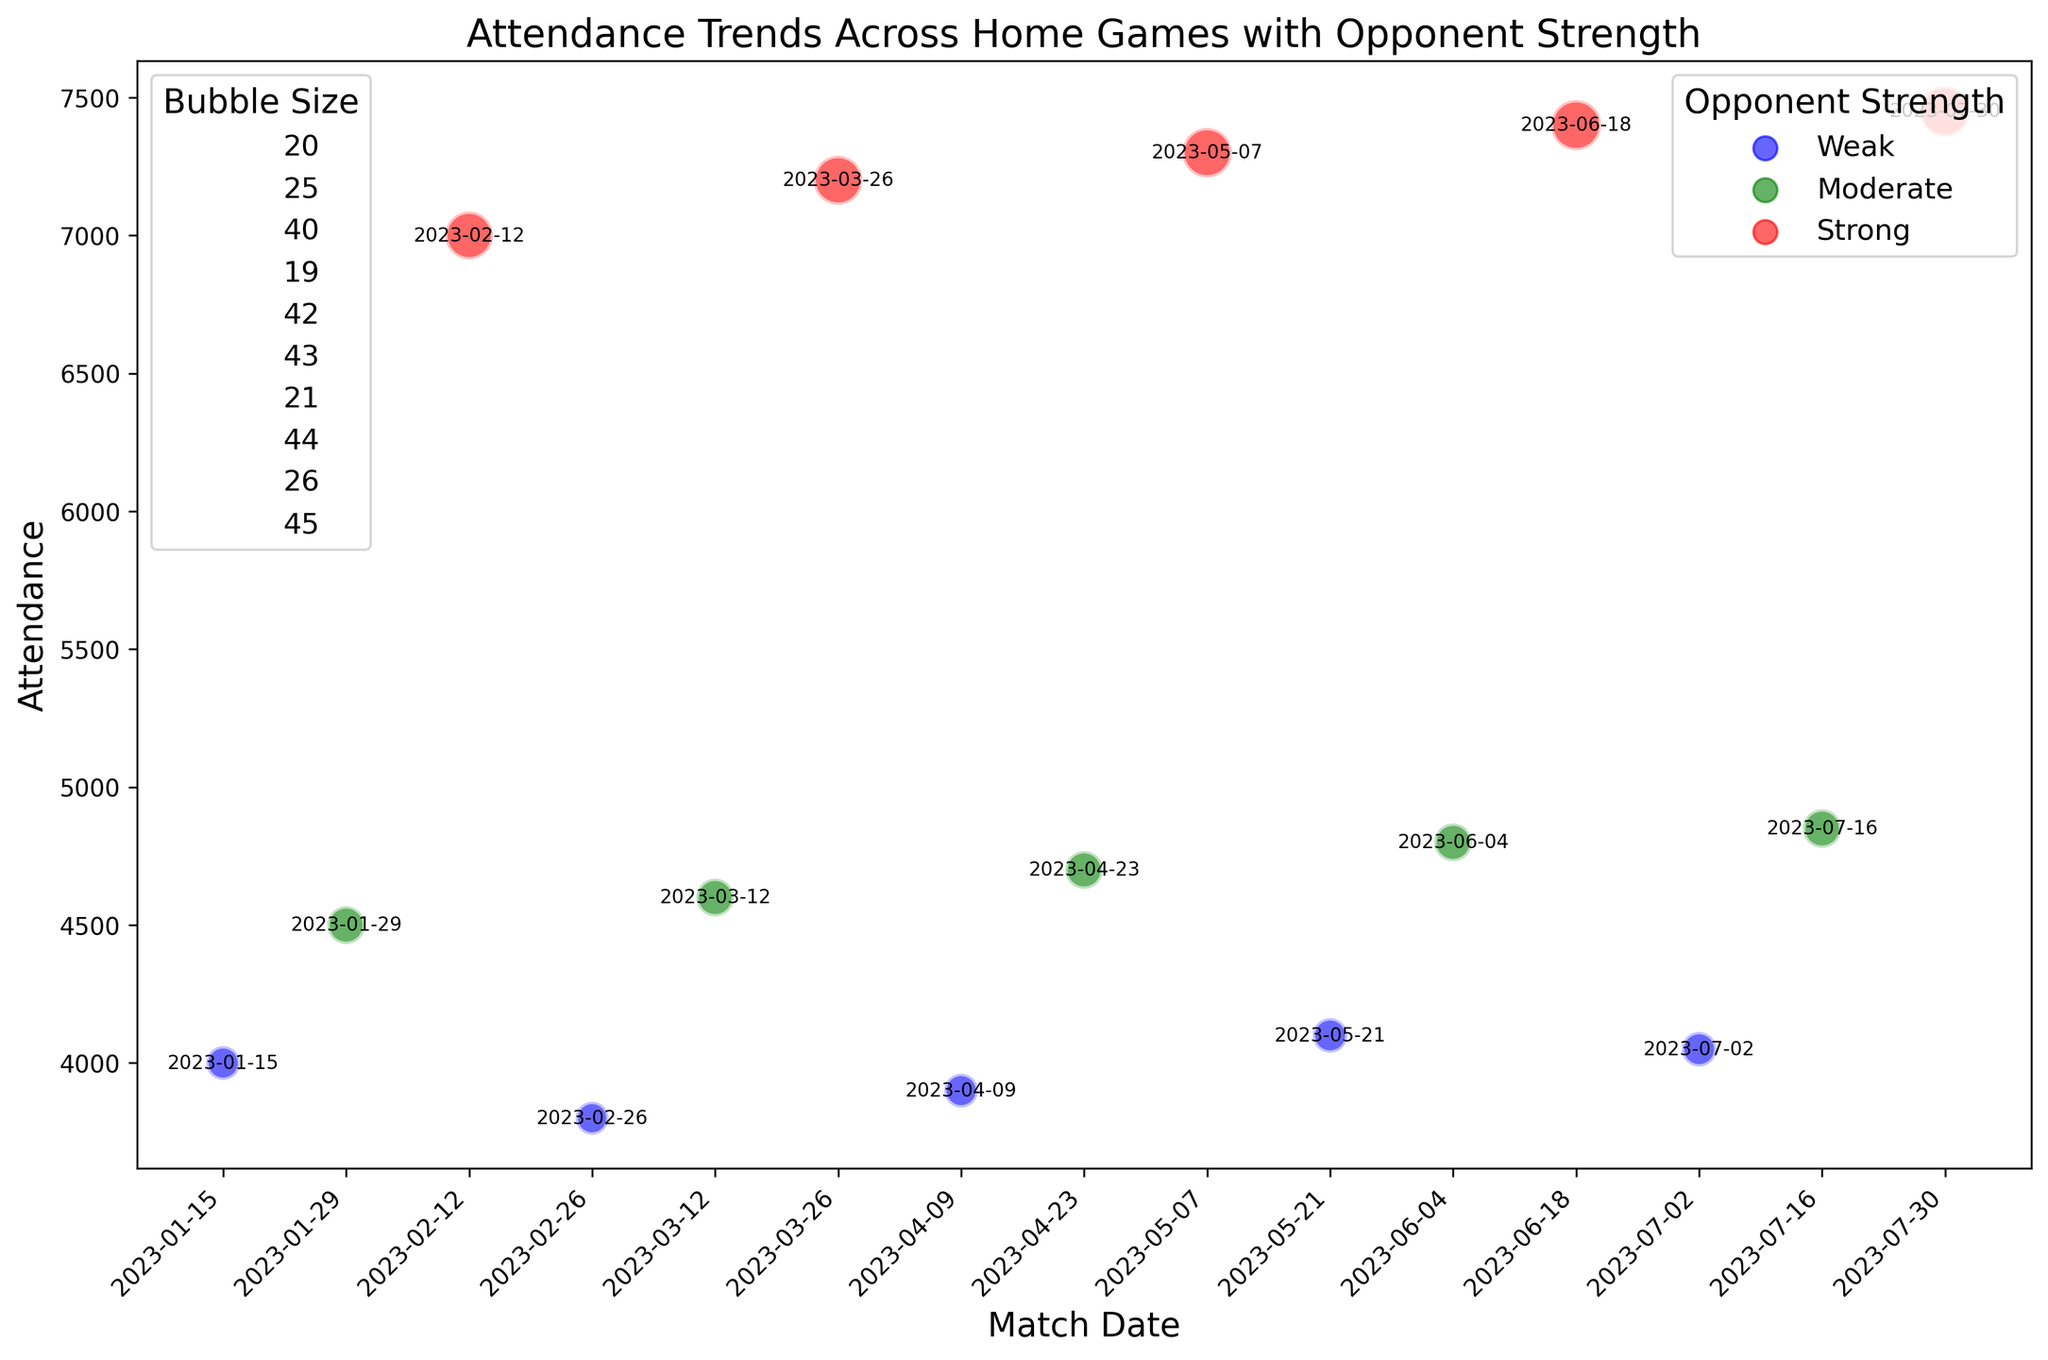Which match had the highest attendance? Look for the bubble that is placed highest on the attendance axis. The highest bubble corresponds to the highest attendance.
Answer: 2023-07-30 How does attendance compare between matches against strong opponents and weak opponents? Observe the relative height of bubbles along the attendance axis. Bubbles for strong opponents are significantly higher than those for weak opponents.
Answer: Higher for strong opponents What's the average attendance for matches against moderate opponents? Sum the attendance figures for all matches against moderate opponents and divide by the number of those matches: (4500 + 4600 + 4700 + 4800 + 4850) / 5.
Answer: 4690 Are there any noticeable attendance trends over time? Assess if there is an overall increase, decrease, or pattern in bubble placements across the timeline. The attendance seems relatively consistent with peaks at intervals corresponding to stronger opponents.
Answer: Peaks during strong opponent games Which match had the largest bubble size, and who was the opponent? Identify the largest bubble visually and note its match date. Then, find the corresponding opponent from the data. The largest bubble size is on 2023-07-30, against a strong opponent.
Answer: 2023-07-30, Strong Is there a correlation between bubble size and attendance? Examine if larger bubbles tend to be placed higher on the attendance axis. Larger bubbles, which correspond to higher attendance, are often observed at the higher end of the attendance axis.
Answer: Positive correlation Compare the differences in attendance between the match on 2023-01-15 and 2023-05-07. Find the attendance values for the specified dates and compute the difference: 7300 (2023-05-07) - 4000 (2023-01-15).
Answer: 3300 What is the trend in attendance for matches against weak opponents over time? Trace the position of bubbles colored blue across the match dates. Despite minor fluctuations, the attendance remains relatively stable for weak opponents.
Answer: Relatively stable What is the rough range of attendance for games against moderate opponents? Identify the lowest and highest attendance figures among the moderate opponents: 4500 (lowest) and 4850 (highest).
Answer: 4500–4850 